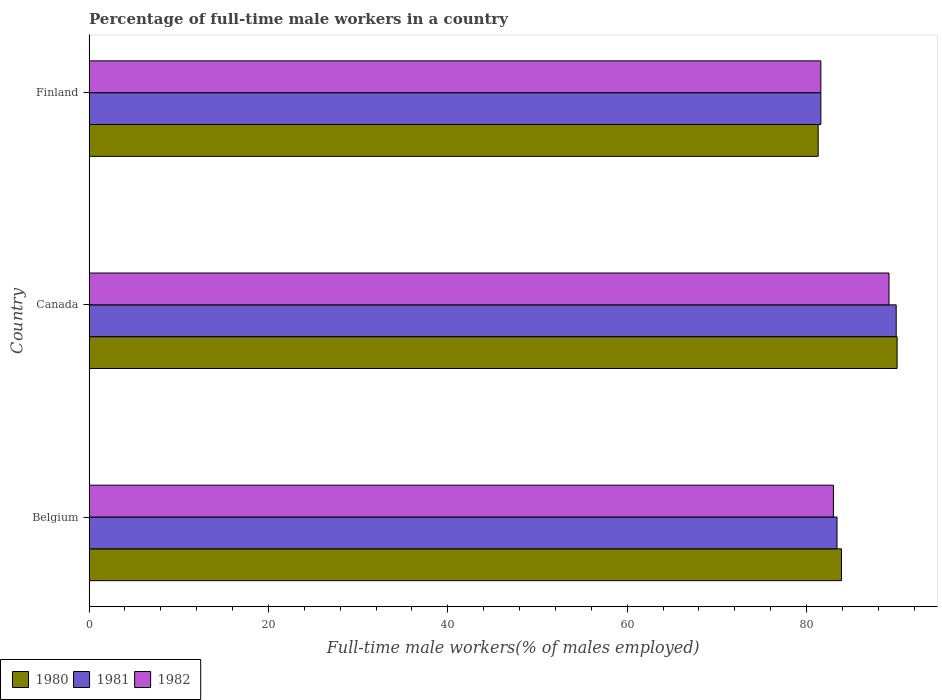Are the number of bars per tick equal to the number of legend labels?
Offer a very short reply. Yes. How many bars are there on the 1st tick from the top?
Provide a short and direct response. 3. What is the label of the 1st group of bars from the top?
Provide a succinct answer. Finland. In how many cases, is the number of bars for a given country not equal to the number of legend labels?
Give a very brief answer. 0. What is the percentage of full-time male workers in 1981 in Belgium?
Ensure brevity in your answer.  83.4. Across all countries, what is the maximum percentage of full-time male workers in 1980?
Ensure brevity in your answer.  90.1. Across all countries, what is the minimum percentage of full-time male workers in 1982?
Your answer should be compact. 81.6. What is the total percentage of full-time male workers in 1981 in the graph?
Keep it short and to the point. 255. What is the difference between the percentage of full-time male workers in 1982 in Belgium and that in Finland?
Make the answer very short. 1.4. What is the difference between the percentage of full-time male workers in 1982 in Finland and the percentage of full-time male workers in 1981 in Belgium?
Make the answer very short. -1.8. What is the average percentage of full-time male workers in 1980 per country?
Keep it short and to the point. 85.1. What is the difference between the percentage of full-time male workers in 1980 and percentage of full-time male workers in 1982 in Canada?
Your answer should be compact. 0.9. In how many countries, is the percentage of full-time male workers in 1981 greater than 88 %?
Offer a terse response. 1. What is the ratio of the percentage of full-time male workers in 1980 in Canada to that in Finland?
Offer a terse response. 1.11. Is the percentage of full-time male workers in 1981 in Belgium less than that in Finland?
Provide a succinct answer. No. Is the difference between the percentage of full-time male workers in 1980 in Belgium and Canada greater than the difference between the percentage of full-time male workers in 1982 in Belgium and Canada?
Your answer should be compact. Yes. What is the difference between the highest and the second highest percentage of full-time male workers in 1980?
Your answer should be very brief. 6.2. What is the difference between the highest and the lowest percentage of full-time male workers in 1981?
Keep it short and to the point. 8.4. In how many countries, is the percentage of full-time male workers in 1980 greater than the average percentage of full-time male workers in 1980 taken over all countries?
Your answer should be compact. 1. Is the sum of the percentage of full-time male workers in 1980 in Belgium and Canada greater than the maximum percentage of full-time male workers in 1981 across all countries?
Offer a very short reply. Yes. Is it the case that in every country, the sum of the percentage of full-time male workers in 1982 and percentage of full-time male workers in 1980 is greater than the percentage of full-time male workers in 1981?
Make the answer very short. Yes. Are all the bars in the graph horizontal?
Offer a terse response. Yes. How many countries are there in the graph?
Offer a terse response. 3. Does the graph contain any zero values?
Your answer should be compact. No. Does the graph contain grids?
Your response must be concise. No. How many legend labels are there?
Provide a succinct answer. 3. What is the title of the graph?
Provide a short and direct response. Percentage of full-time male workers in a country. What is the label or title of the X-axis?
Keep it short and to the point. Full-time male workers(% of males employed). What is the Full-time male workers(% of males employed) in 1980 in Belgium?
Make the answer very short. 83.9. What is the Full-time male workers(% of males employed) of 1981 in Belgium?
Ensure brevity in your answer.  83.4. What is the Full-time male workers(% of males employed) in 1982 in Belgium?
Offer a terse response. 83. What is the Full-time male workers(% of males employed) in 1980 in Canada?
Provide a short and direct response. 90.1. What is the Full-time male workers(% of males employed) in 1982 in Canada?
Your answer should be very brief. 89.2. What is the Full-time male workers(% of males employed) of 1980 in Finland?
Provide a short and direct response. 81.3. What is the Full-time male workers(% of males employed) of 1981 in Finland?
Offer a very short reply. 81.6. What is the Full-time male workers(% of males employed) of 1982 in Finland?
Your answer should be very brief. 81.6. Across all countries, what is the maximum Full-time male workers(% of males employed) in 1980?
Keep it short and to the point. 90.1. Across all countries, what is the maximum Full-time male workers(% of males employed) in 1981?
Your response must be concise. 90. Across all countries, what is the maximum Full-time male workers(% of males employed) of 1982?
Give a very brief answer. 89.2. Across all countries, what is the minimum Full-time male workers(% of males employed) of 1980?
Offer a very short reply. 81.3. Across all countries, what is the minimum Full-time male workers(% of males employed) of 1981?
Your response must be concise. 81.6. Across all countries, what is the minimum Full-time male workers(% of males employed) in 1982?
Make the answer very short. 81.6. What is the total Full-time male workers(% of males employed) in 1980 in the graph?
Offer a terse response. 255.3. What is the total Full-time male workers(% of males employed) in 1981 in the graph?
Offer a terse response. 255. What is the total Full-time male workers(% of males employed) in 1982 in the graph?
Your response must be concise. 253.8. What is the difference between the Full-time male workers(% of males employed) in 1981 in Belgium and that in Canada?
Offer a terse response. -6.6. What is the difference between the Full-time male workers(% of males employed) in 1982 in Belgium and that in Canada?
Your answer should be compact. -6.2. What is the difference between the Full-time male workers(% of males employed) of 1980 in Belgium and that in Finland?
Provide a short and direct response. 2.6. What is the difference between the Full-time male workers(% of males employed) in 1981 in Belgium and that in Finland?
Ensure brevity in your answer.  1.8. What is the difference between the Full-time male workers(% of males employed) of 1982 in Belgium and that in Finland?
Your answer should be very brief. 1.4. What is the difference between the Full-time male workers(% of males employed) of 1981 in Canada and that in Finland?
Keep it short and to the point. 8.4. What is the difference between the Full-time male workers(% of males employed) of 1982 in Canada and that in Finland?
Offer a terse response. 7.6. What is the difference between the Full-time male workers(% of males employed) of 1980 in Belgium and the Full-time male workers(% of males employed) of 1982 in Canada?
Your answer should be very brief. -5.3. What is the difference between the Full-time male workers(% of males employed) of 1980 in Belgium and the Full-time male workers(% of males employed) of 1981 in Finland?
Make the answer very short. 2.3. What is the difference between the Full-time male workers(% of males employed) in 1981 in Belgium and the Full-time male workers(% of males employed) in 1982 in Finland?
Provide a succinct answer. 1.8. What is the difference between the Full-time male workers(% of males employed) in 1980 in Canada and the Full-time male workers(% of males employed) in 1981 in Finland?
Make the answer very short. 8.5. What is the average Full-time male workers(% of males employed) in 1980 per country?
Your response must be concise. 85.1. What is the average Full-time male workers(% of males employed) in 1981 per country?
Give a very brief answer. 85. What is the average Full-time male workers(% of males employed) of 1982 per country?
Ensure brevity in your answer.  84.6. What is the difference between the Full-time male workers(% of males employed) of 1980 and Full-time male workers(% of males employed) of 1981 in Belgium?
Ensure brevity in your answer.  0.5. What is the difference between the Full-time male workers(% of males employed) in 1980 and Full-time male workers(% of males employed) in 1982 in Belgium?
Keep it short and to the point. 0.9. What is the difference between the Full-time male workers(% of males employed) of 1981 and Full-time male workers(% of males employed) of 1982 in Canada?
Your response must be concise. 0.8. What is the difference between the Full-time male workers(% of males employed) of 1981 and Full-time male workers(% of males employed) of 1982 in Finland?
Keep it short and to the point. 0. What is the ratio of the Full-time male workers(% of males employed) in 1980 in Belgium to that in Canada?
Give a very brief answer. 0.93. What is the ratio of the Full-time male workers(% of males employed) of 1981 in Belgium to that in Canada?
Provide a short and direct response. 0.93. What is the ratio of the Full-time male workers(% of males employed) of 1982 in Belgium to that in Canada?
Provide a succinct answer. 0.93. What is the ratio of the Full-time male workers(% of males employed) of 1980 in Belgium to that in Finland?
Offer a terse response. 1.03. What is the ratio of the Full-time male workers(% of males employed) of 1981 in Belgium to that in Finland?
Keep it short and to the point. 1.02. What is the ratio of the Full-time male workers(% of males employed) of 1982 in Belgium to that in Finland?
Provide a succinct answer. 1.02. What is the ratio of the Full-time male workers(% of males employed) in 1980 in Canada to that in Finland?
Make the answer very short. 1.11. What is the ratio of the Full-time male workers(% of males employed) in 1981 in Canada to that in Finland?
Ensure brevity in your answer.  1.1. What is the ratio of the Full-time male workers(% of males employed) in 1982 in Canada to that in Finland?
Your answer should be compact. 1.09. What is the difference between the highest and the second highest Full-time male workers(% of males employed) in 1980?
Provide a short and direct response. 6.2. What is the difference between the highest and the second highest Full-time male workers(% of males employed) of 1981?
Your response must be concise. 6.6. What is the difference between the highest and the second highest Full-time male workers(% of males employed) of 1982?
Provide a short and direct response. 6.2. What is the difference between the highest and the lowest Full-time male workers(% of males employed) of 1982?
Give a very brief answer. 7.6. 